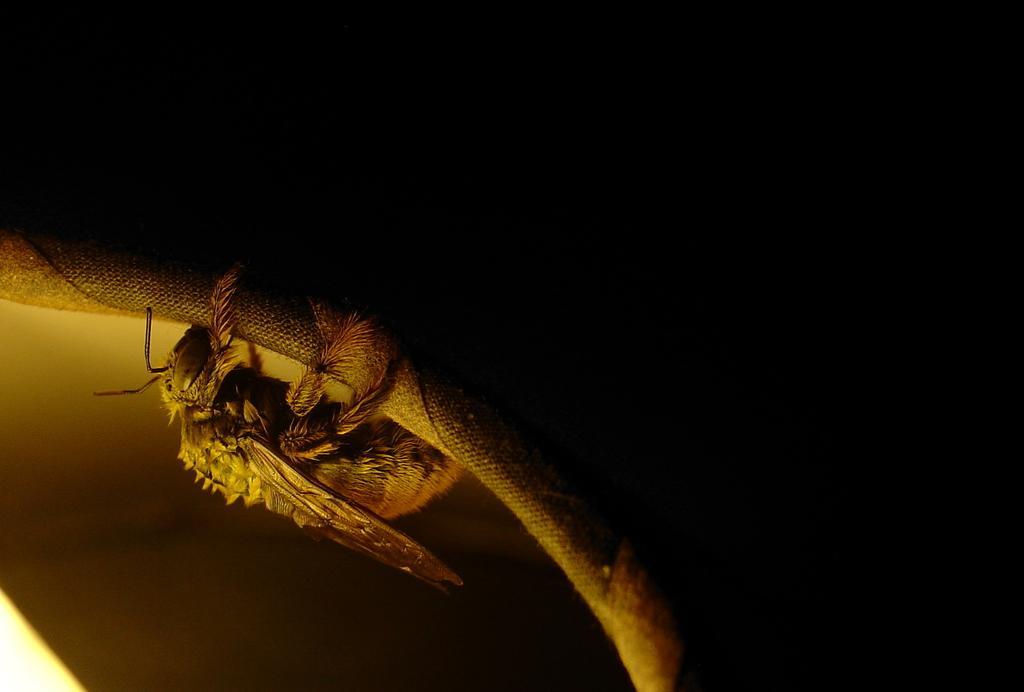How would you summarize this image in a sentence or two? In this image there is an insect laying on some surface. 